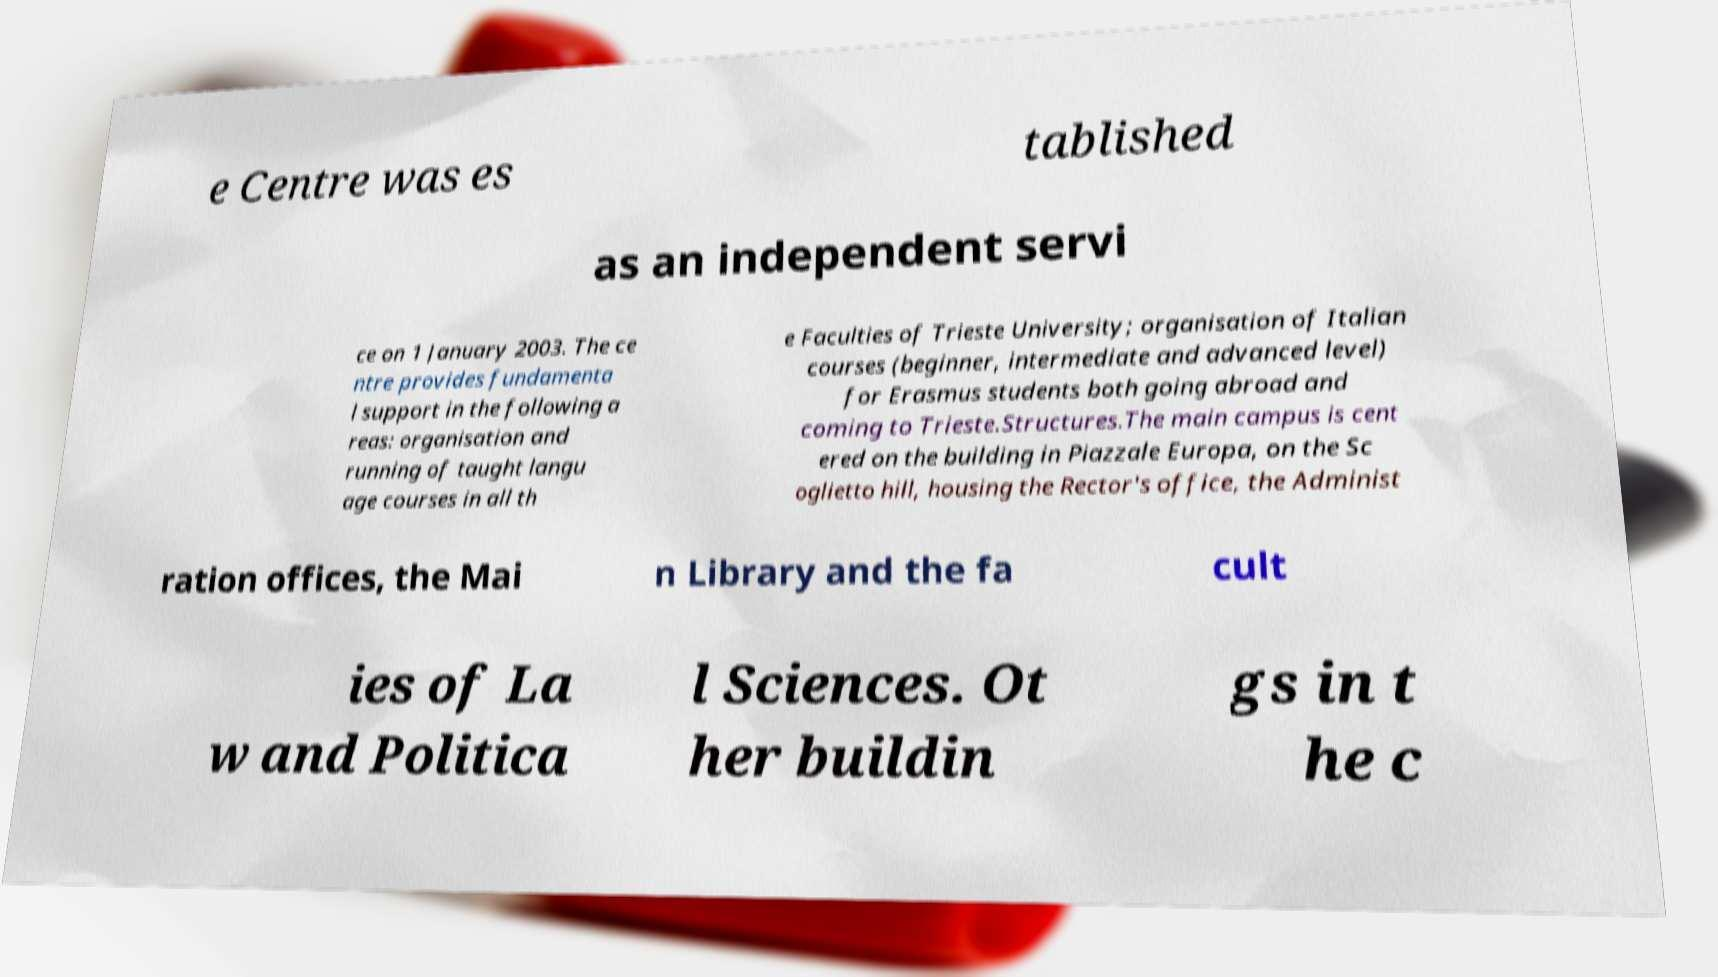Please read and relay the text visible in this image. What does it say? e Centre was es tablished as an independent servi ce on 1 January 2003. The ce ntre provides fundamenta l support in the following a reas: organisation and running of taught langu age courses in all th e Faculties of Trieste University; organisation of Italian courses (beginner, intermediate and advanced level) for Erasmus students both going abroad and coming to Trieste.Structures.The main campus is cent ered on the building in Piazzale Europa, on the Sc oglietto hill, housing the Rector's office, the Administ ration offices, the Mai n Library and the fa cult ies of La w and Politica l Sciences. Ot her buildin gs in t he c 